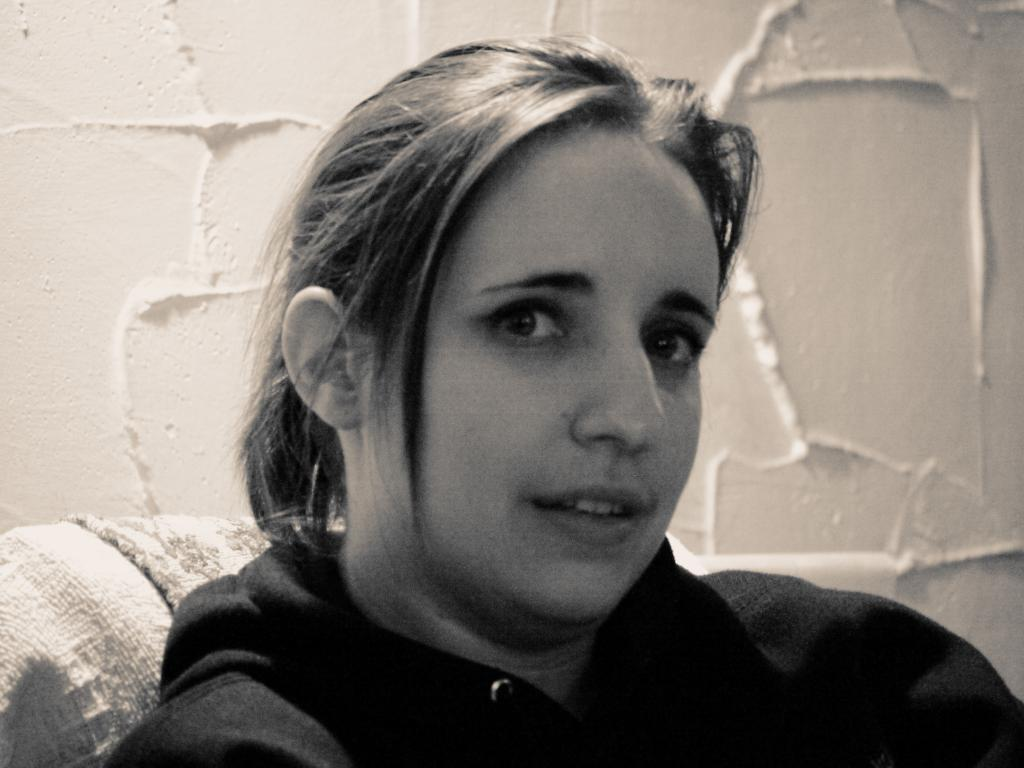Who is present in the image? There is a woman in the image. What is the woman doing in the image? The woman is sitting on a chair in the image. What can be seen in the background of the image? There is a wall in the background of the image. What type of quiver can be seen on the wall in the image? There is no quiver present in the image; only the woman and the wall are visible. 